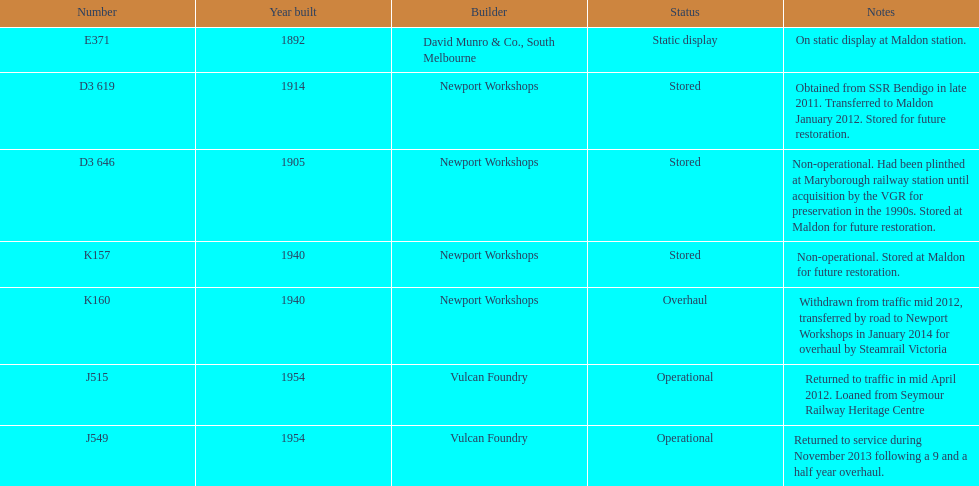How many of the engines were created before 1940? 3. 